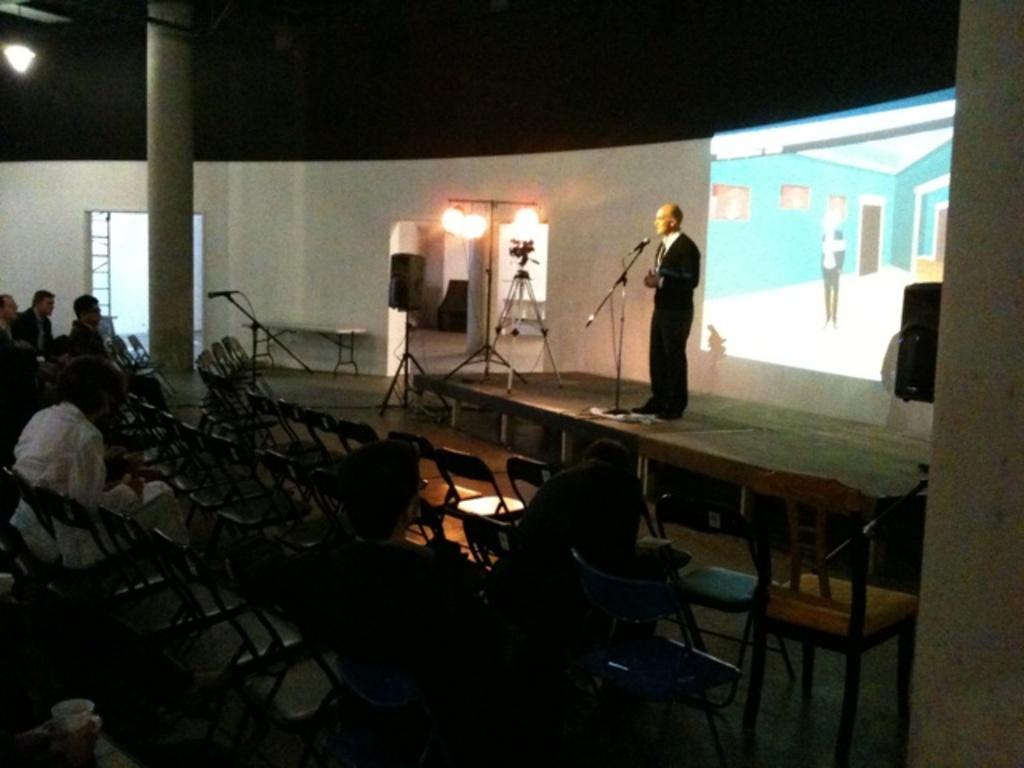Describe this image in one or two sentences. There is a person standing on the stage and he is speaking on a microphone. Here we can see a few persons sitting on a chair and paying attention to the speaker. In the background we can see a screen and here we can see a camera. 